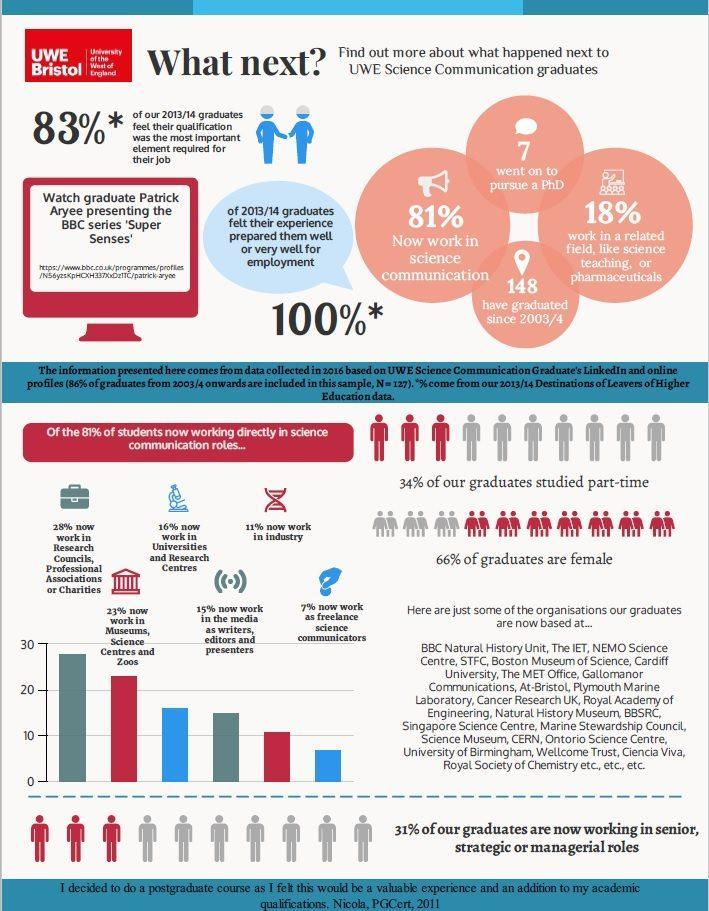What is the total number of science communication graduates in UWE since 2003/2004?
Answer the question with a short phrase. 148 What percentage of UWE science communication graduates do not work in the same stream? 19% How many UWE science communication graduates of 2013/14 batch went on to pursue a PhD? 7 Out of total students working in the science communication roles, what percentage of graduates currently work as freelance science communicators? 7% What percentage of UWE science communication graduates of 2013/14 batch are male? 34% 